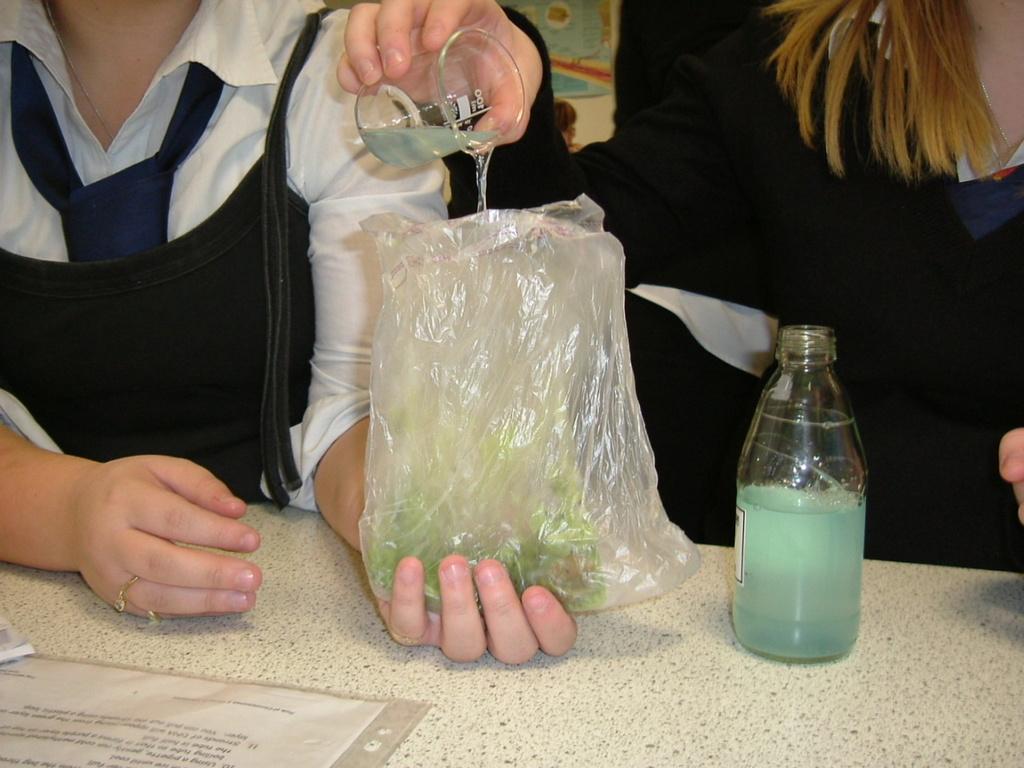Can you describe this image briefly? In this image it seems like there is a woman who is pouring the chemical in to the cover. There is a table in front of the two women. On the table there is glass flask and a file. 